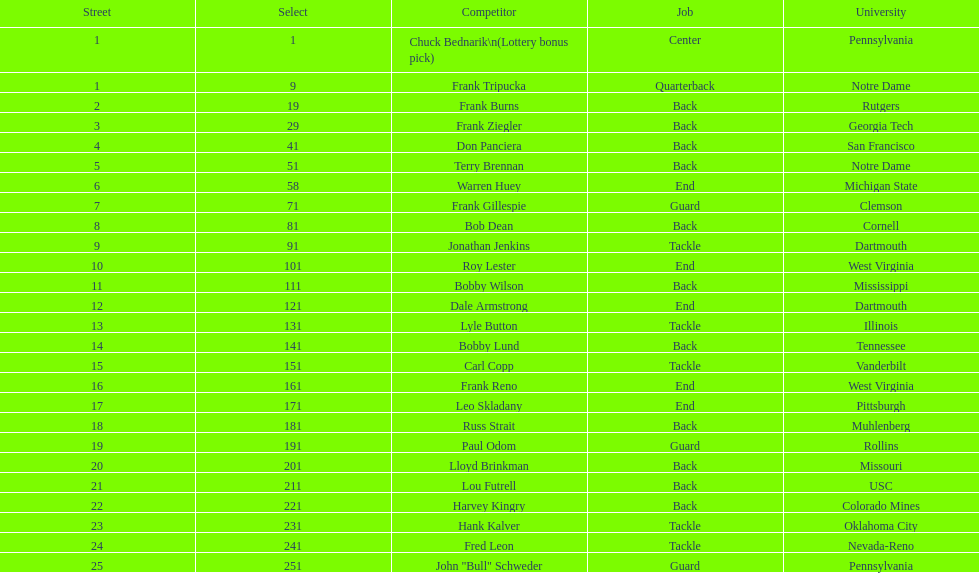Was chuck bednarik or frank tripucka the first draft pick? Chuck Bednarik. Could you help me parse every detail presented in this table? {'header': ['Street', 'Select', 'Competitor', 'Job', 'University'], 'rows': [['1', '1', 'Chuck Bednarik\\n(Lottery bonus pick)', 'Center', 'Pennsylvania'], ['1', '9', 'Frank Tripucka', 'Quarterback', 'Notre Dame'], ['2', '19', 'Frank Burns', 'Back', 'Rutgers'], ['3', '29', 'Frank Ziegler', 'Back', 'Georgia Tech'], ['4', '41', 'Don Panciera', 'Back', 'San Francisco'], ['5', '51', 'Terry Brennan', 'Back', 'Notre Dame'], ['6', '58', 'Warren Huey', 'End', 'Michigan State'], ['7', '71', 'Frank Gillespie', 'Guard', 'Clemson'], ['8', '81', 'Bob Dean', 'Back', 'Cornell'], ['9', '91', 'Jonathan Jenkins', 'Tackle', 'Dartmouth'], ['10', '101', 'Roy Lester', 'End', 'West Virginia'], ['11', '111', 'Bobby Wilson', 'Back', 'Mississippi'], ['12', '121', 'Dale Armstrong', 'End', 'Dartmouth'], ['13', '131', 'Lyle Button', 'Tackle', 'Illinois'], ['14', '141', 'Bobby Lund', 'Back', 'Tennessee'], ['15', '151', 'Carl Copp', 'Tackle', 'Vanderbilt'], ['16', '161', 'Frank Reno', 'End', 'West Virginia'], ['17', '171', 'Leo Skladany', 'End', 'Pittsburgh'], ['18', '181', 'Russ Strait', 'Back', 'Muhlenberg'], ['19', '191', 'Paul Odom', 'Guard', 'Rollins'], ['20', '201', 'Lloyd Brinkman', 'Back', 'Missouri'], ['21', '211', 'Lou Futrell', 'Back', 'USC'], ['22', '221', 'Harvey Kingry', 'Back', 'Colorado Mines'], ['23', '231', 'Hank Kalver', 'Tackle', 'Oklahoma City'], ['24', '241', 'Fred Leon', 'Tackle', 'Nevada-Reno'], ['25', '251', 'John "Bull" Schweder', 'Guard', 'Pennsylvania']]} 